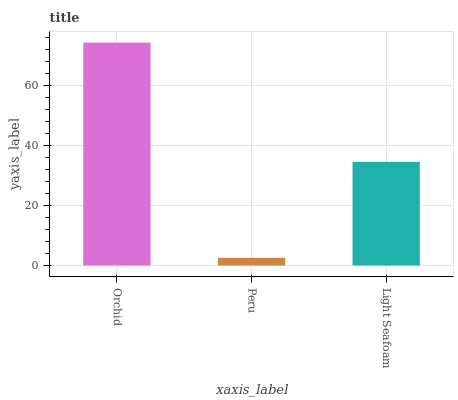Is Peru the minimum?
Answer yes or no. Yes. Is Orchid the maximum?
Answer yes or no. Yes. Is Light Seafoam the minimum?
Answer yes or no. No. Is Light Seafoam the maximum?
Answer yes or no. No. Is Light Seafoam greater than Peru?
Answer yes or no. Yes. Is Peru less than Light Seafoam?
Answer yes or no. Yes. Is Peru greater than Light Seafoam?
Answer yes or no. No. Is Light Seafoam less than Peru?
Answer yes or no. No. Is Light Seafoam the high median?
Answer yes or no. Yes. Is Light Seafoam the low median?
Answer yes or no. Yes. Is Peru the high median?
Answer yes or no. No. Is Orchid the low median?
Answer yes or no. No. 